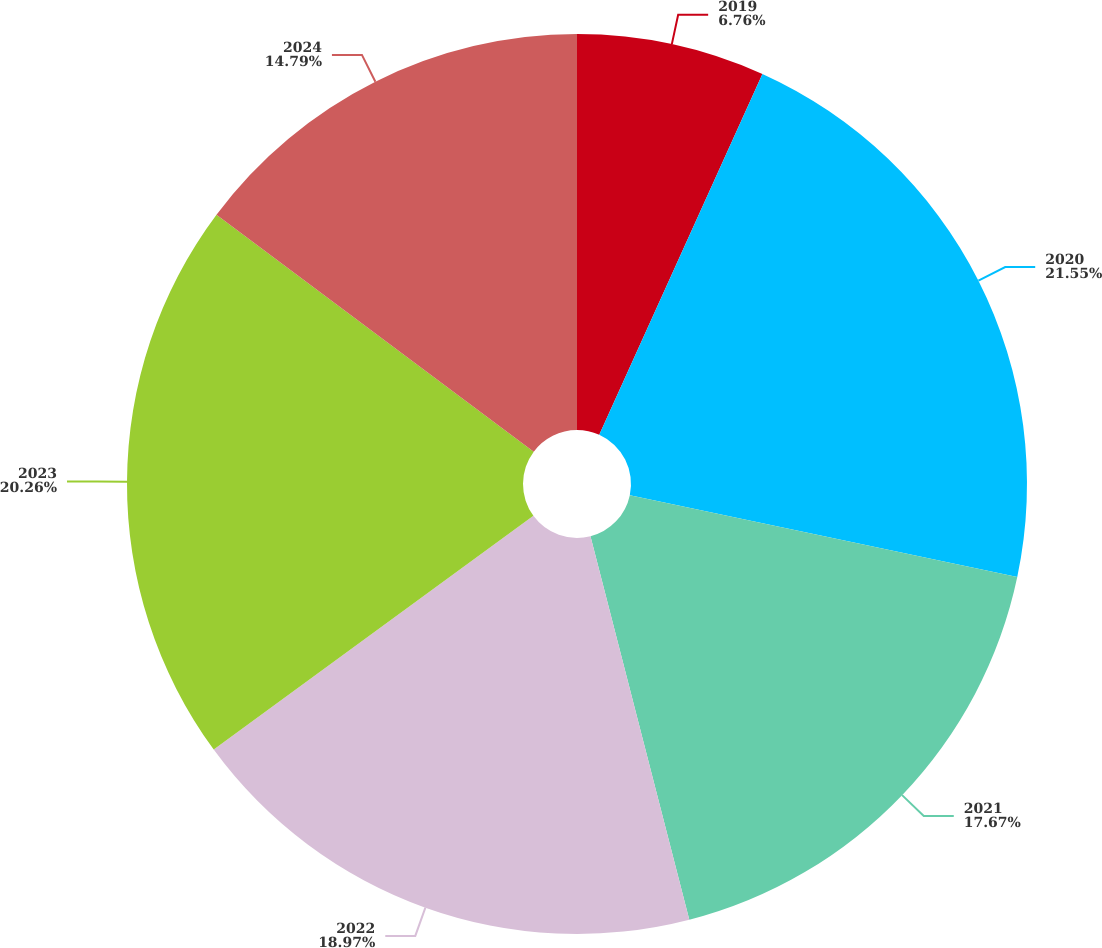<chart> <loc_0><loc_0><loc_500><loc_500><pie_chart><fcel>2019<fcel>2020<fcel>2021<fcel>2022<fcel>2023<fcel>2024<nl><fcel>6.76%<fcel>21.56%<fcel>17.67%<fcel>18.97%<fcel>20.26%<fcel>14.79%<nl></chart> 